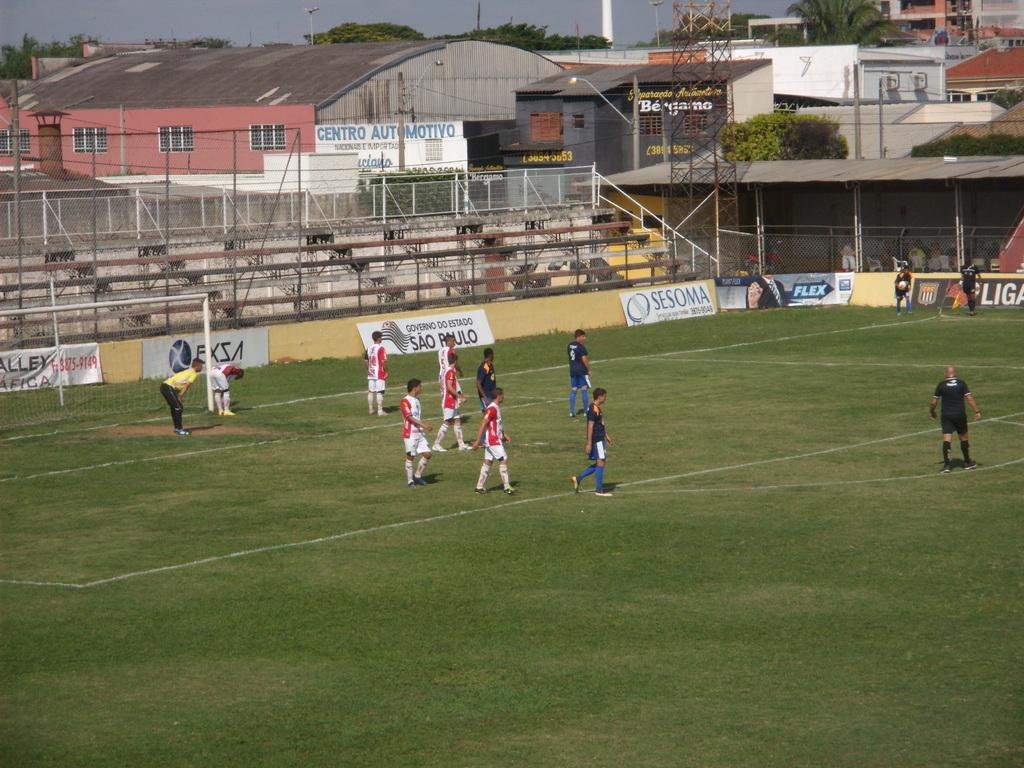Provide a one-sentence caption for the provided image. Young boys play soccer on a field sponsored by Sesoma and Flex. 